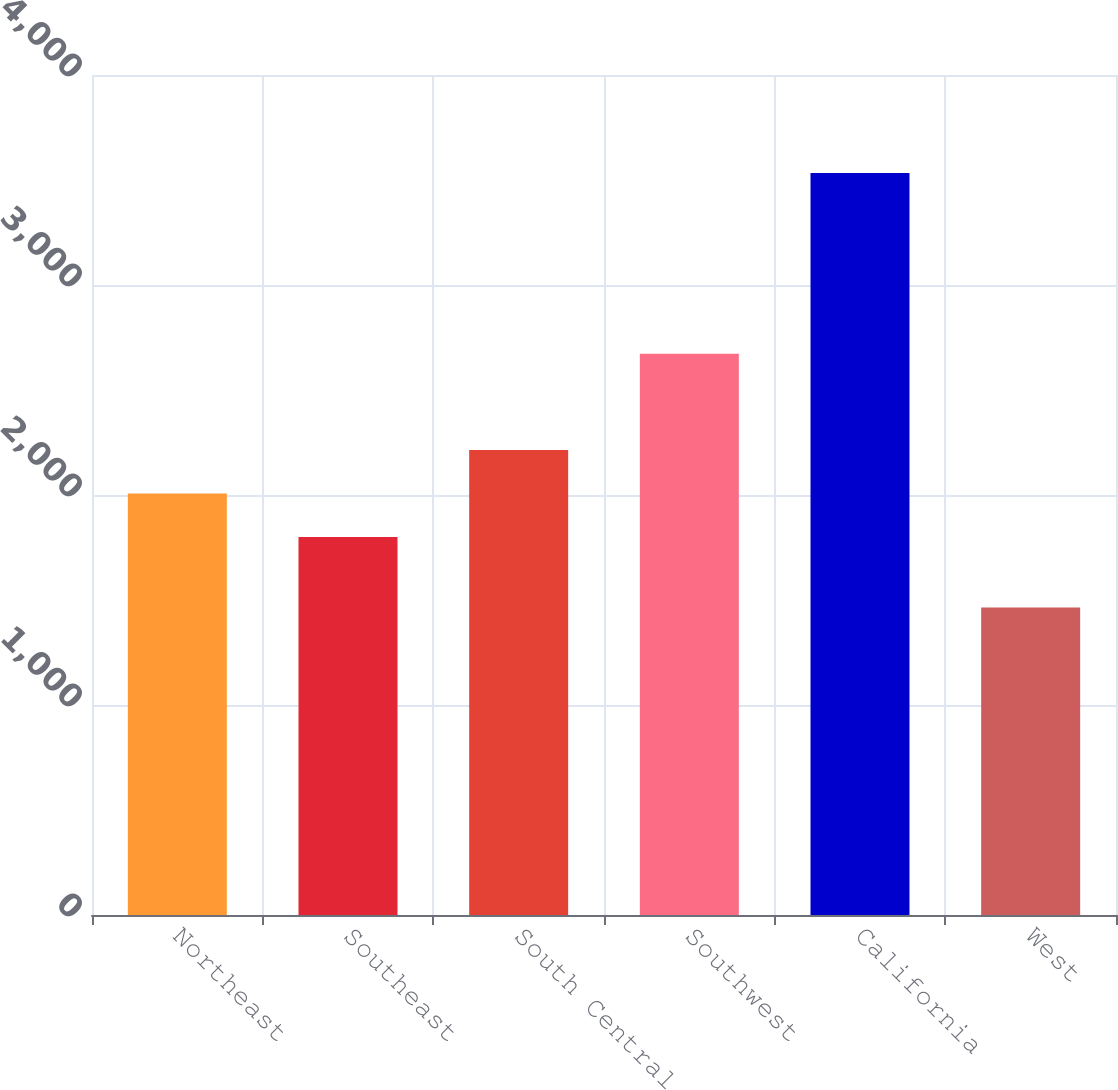Convert chart. <chart><loc_0><loc_0><loc_500><loc_500><bar_chart><fcel>Northeast<fcel>Southeast<fcel>South Central<fcel>Southwest<fcel>California<fcel>West<nl><fcel>2007.09<fcel>1800.2<fcel>2213.98<fcel>2672.1<fcel>3533.5<fcel>1464.6<nl></chart> 